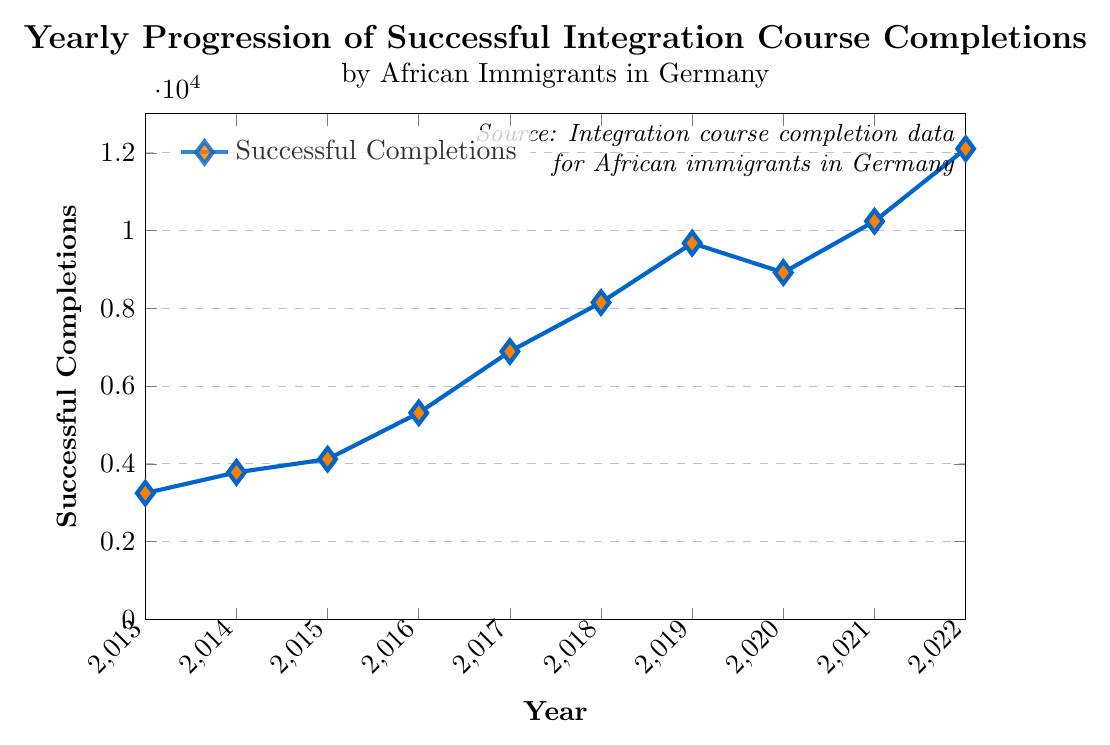Which year had the highest number of successful completions? By visually inspecting the plot, the highest point on the line occurs in the year 2022. The corresponding completion count for that year is the y-axis value at that point.
Answer: 2022 What was the percentage increase in successful completions from 2013 to 2014? The number of completions in 2013 is 3245, and in 2014 it is 3780. To calculate the percentage increase: ((3780 - 3245) / 3245) * 100.
Answer: 16.46% By how much did successful completions decrease from 2019 to 2020? The number of completions in 2019 is 9675, and in 2020 it is 8920. Subtract the 2020 value from the 2019 value: 9675 - 8920.
Answer: 755 What is the trend in successful completions from 2015 to 2018? The data from 2015 to 2018 are 4120, 5310, 6890, and 8150 respectively. Each year the number of completions increases, indicating an upward trend in successful completions.
Answer: Upward trend Which year saw the lowest number of successful completions, and what was the count? By examining the plot, the lowest point on the line is in 2013. The y-axis value at that point represents the lowest number of completions.
Answer: 2013, 3245 Calculate the total number of successful completions from 2013 to 2022. Add up all the completion values from each year: 3245 + 3780 + 4120 + 5310 + 6890 + 8150 + 9675 + 8920 + 10240 + 12105.
Answer: 72535 In which year did successful completions surpass 8000 for the first time? Looking at the y-axis values and matching them against the x-axis years, the first year the number surpassed 8000 is 2018.
Answer: 2018 Was there any year when the number of successful completions decreased compared to the previous year? If so, which year? Comparing the values year-over-year, the only visible decrease is from 2019 to 2020.
Answer: 2020 